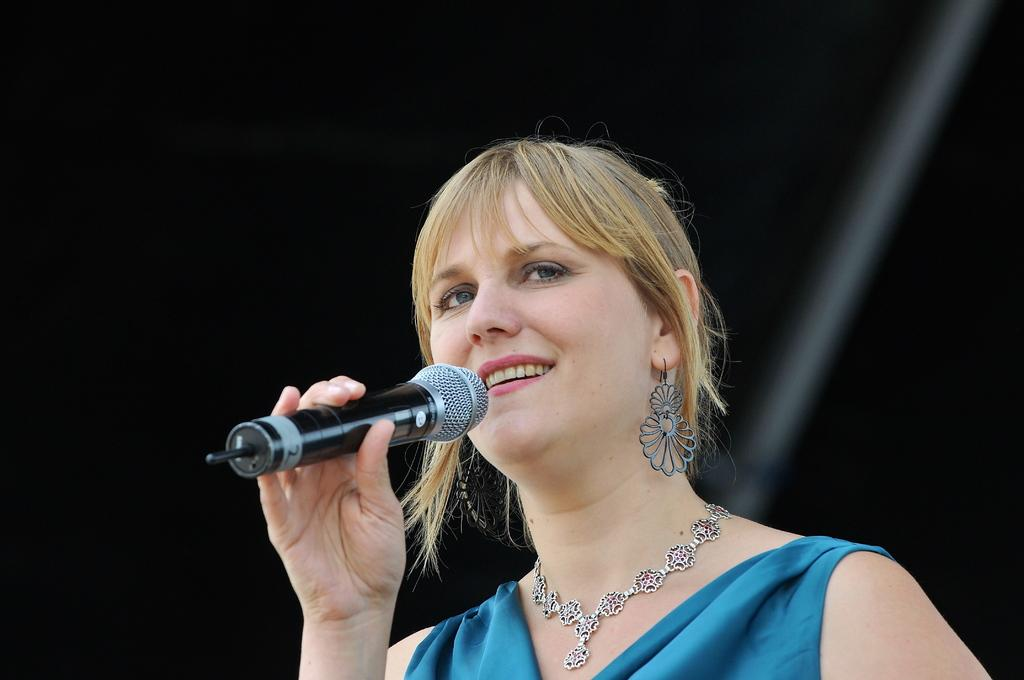Who is the main subject in the image? There is a woman in the image. What is the woman doing in the image? The woman is smiling and holding a microphone in her hand. What accessory is the woman wearing in the image? The woman is wearing a necklace. What is the color of the background in the image? The background of the image is dark. What type of scent can be detected from the woman in the image? There is no information about the scent of the woman in the image, so it cannot be determined. Is there an actor present in the image? The image only features a woman, and there is no mention of an actor. 